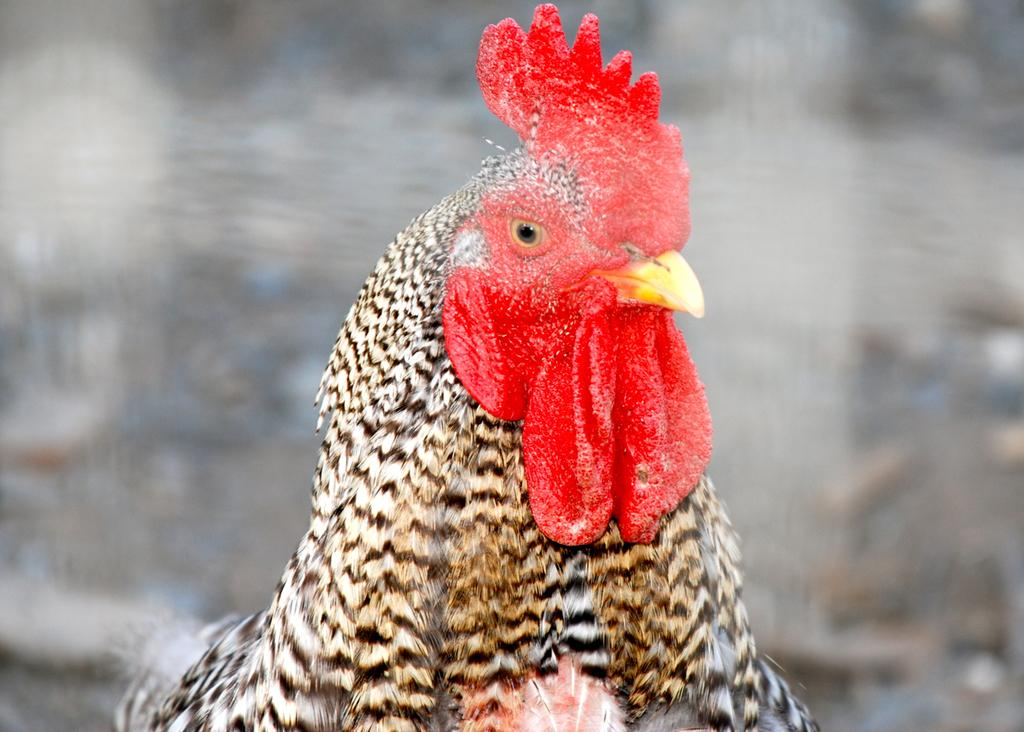What type of animal is in the image? There is a cock in the image. What colors are present in the cock's feathers? The cock's feathers are black and white in color. Is there a volcano erupting in the background of the image? There is no volcano present in the image. Can you tell me which team the cock is representing in the image? The image does not depict a team or any team-related context. 